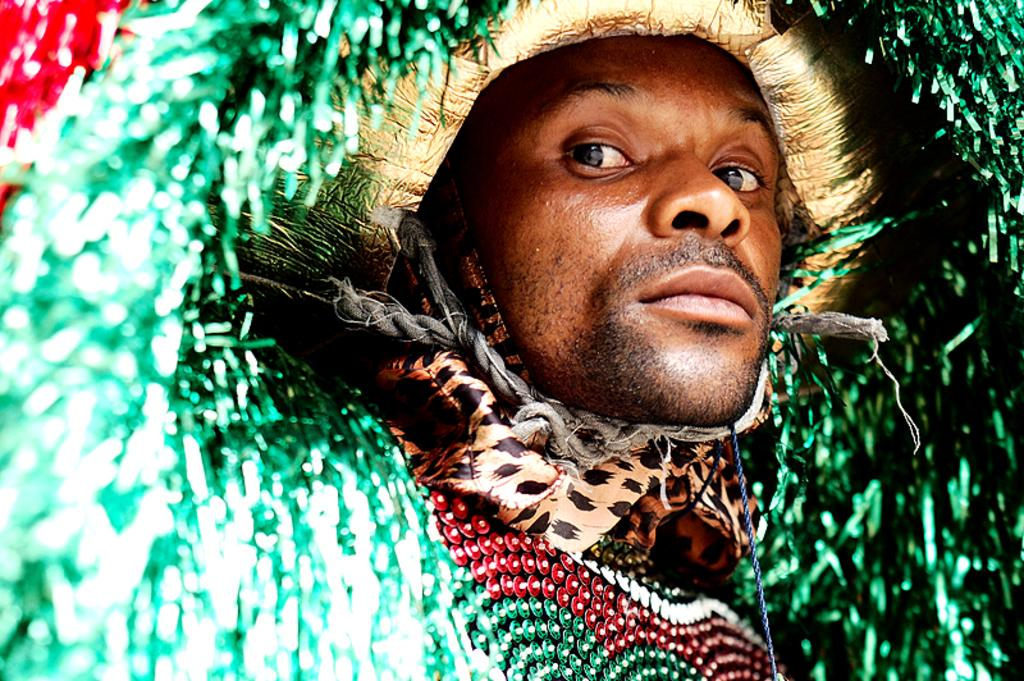Who is present in the image? There is a man in the image. What is the man wearing? The man is wearing a fancy dress. Can you describe the colors of the fancy dress? The fancy dress is green and red in color. What type of punishment is the man receiving in the image? There is no indication of punishment in the image; the man is simply wearing a fancy dress. 